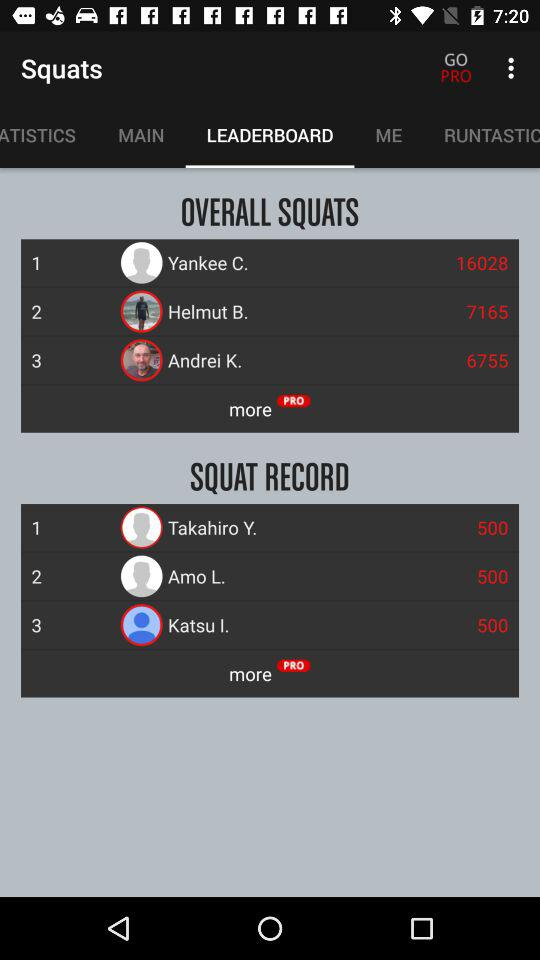Which tab is selected? The selected tab is "LEADERBOARD". 